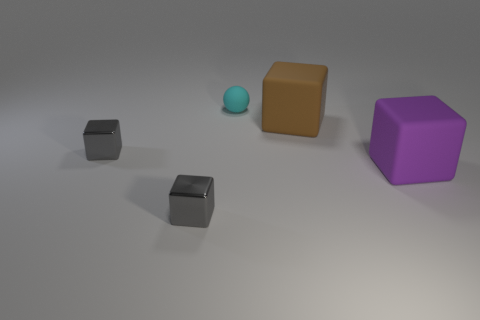Do the gray block that is behind the purple rubber thing and the large purple matte block have the same size?
Your answer should be compact. No. Is there any other thing that has the same shape as the small matte thing?
Ensure brevity in your answer.  No. Does the small cyan sphere have the same material as the tiny gray cube that is in front of the purple block?
Give a very brief answer. No. Is the number of cyan rubber balls to the left of the tiny cyan thing less than the number of big brown things?
Your response must be concise. Yes. Is there a gray thing that has the same material as the tiny ball?
Offer a terse response. No. What is the material of the block that is the same size as the brown matte object?
Your answer should be very brief. Rubber. Are there fewer small rubber things that are behind the cyan matte ball than small cyan matte balls that are right of the brown matte object?
Your response must be concise. No. What is the shape of the object that is behind the big purple matte object and in front of the brown cube?
Make the answer very short. Cube. What number of metallic things are the same shape as the small cyan matte thing?
Keep it short and to the point. 0. There is a purple thing that is made of the same material as the small cyan sphere; what size is it?
Provide a succinct answer. Large. 